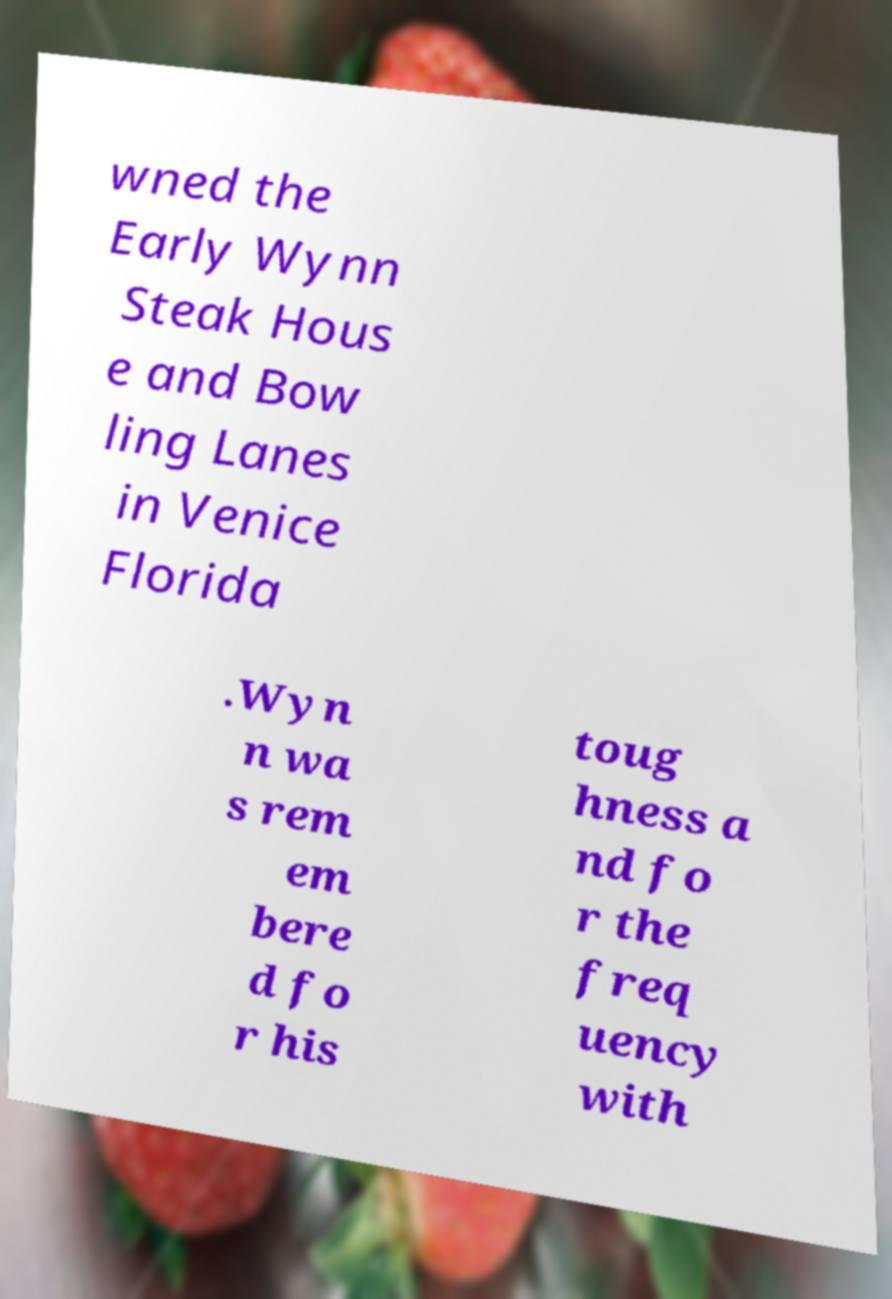Can you accurately transcribe the text from the provided image for me? wned the Early Wynn Steak Hous e and Bow ling Lanes in Venice Florida .Wyn n wa s rem em bere d fo r his toug hness a nd fo r the freq uency with 